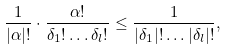Convert formula to latex. <formula><loc_0><loc_0><loc_500><loc_500>\frac { 1 } { | \alpha | ! } \cdot \frac { \alpha ! } { \delta _ { 1 } ! \dots \delta _ { l } ! } \leq \frac { 1 } { | \delta _ { 1 } | ! \dots | \delta _ { l } | ! } ,</formula> 